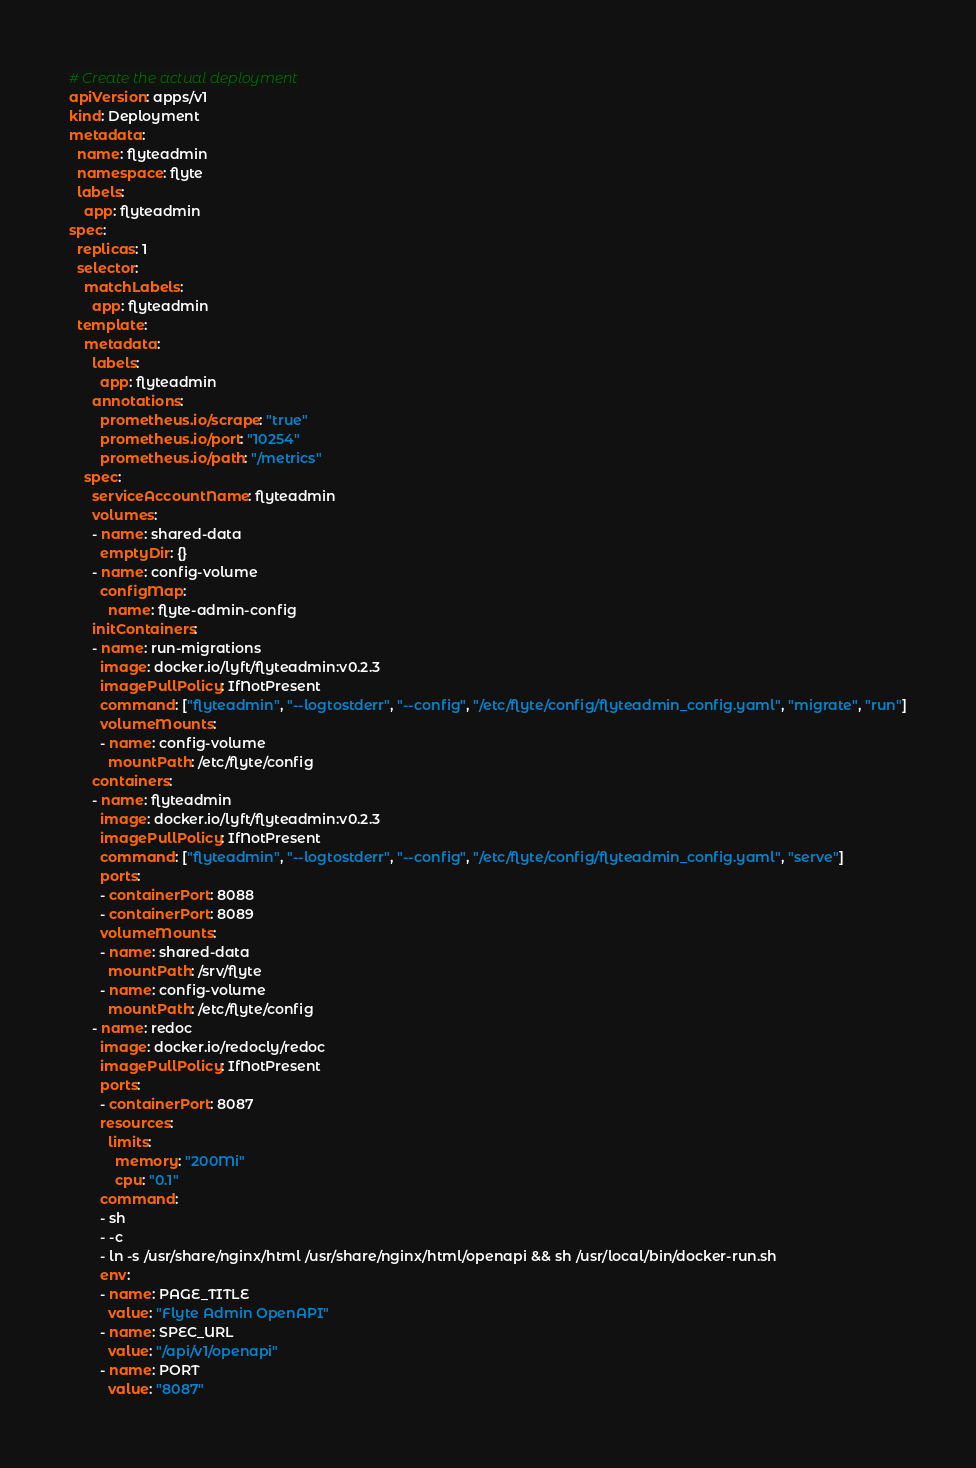<code> <loc_0><loc_0><loc_500><loc_500><_YAML_># Create the actual deployment
apiVersion: apps/v1
kind: Deployment
metadata:
  name: flyteadmin
  namespace: flyte
  labels:
    app: flyteadmin
spec:
  replicas: 1
  selector:
    matchLabels:
      app: flyteadmin
  template:
    metadata:
      labels:
        app: flyteadmin
      annotations:
        prometheus.io/scrape: "true"
        prometheus.io/port: "10254"
        prometheus.io/path: "/metrics"
    spec:
      serviceAccountName: flyteadmin
      volumes:
      - name: shared-data
        emptyDir: {}
      - name: config-volume
        configMap:
          name: flyte-admin-config
      initContainers:
      - name: run-migrations
        image: docker.io/lyft/flyteadmin:v0.2.3
        imagePullPolicy: IfNotPresent
        command: ["flyteadmin", "--logtostderr", "--config", "/etc/flyte/config/flyteadmin_config.yaml", "migrate", "run"]
        volumeMounts:
        - name: config-volume
          mountPath: /etc/flyte/config
      containers:
      - name: flyteadmin
        image: docker.io/lyft/flyteadmin:v0.2.3
        imagePullPolicy: IfNotPresent
        command: ["flyteadmin", "--logtostderr", "--config", "/etc/flyte/config/flyteadmin_config.yaml", "serve"]
        ports:
        - containerPort: 8088
        - containerPort: 8089
        volumeMounts:
        - name: shared-data
          mountPath: /srv/flyte
        - name: config-volume
          mountPath: /etc/flyte/config
      - name: redoc
        image: docker.io/redocly/redoc
        imagePullPolicy: IfNotPresent
        ports:
        - containerPort: 8087
        resources:
          limits:
            memory: "200Mi"
            cpu: "0.1"
        command:
        - sh
        - -c
        - ln -s /usr/share/nginx/html /usr/share/nginx/html/openapi && sh /usr/local/bin/docker-run.sh
        env:
        - name: PAGE_TITLE
          value: "Flyte Admin OpenAPI"
        - name: SPEC_URL
          value: "/api/v1/openapi"
        - name: PORT
          value: "8087"
</code> 